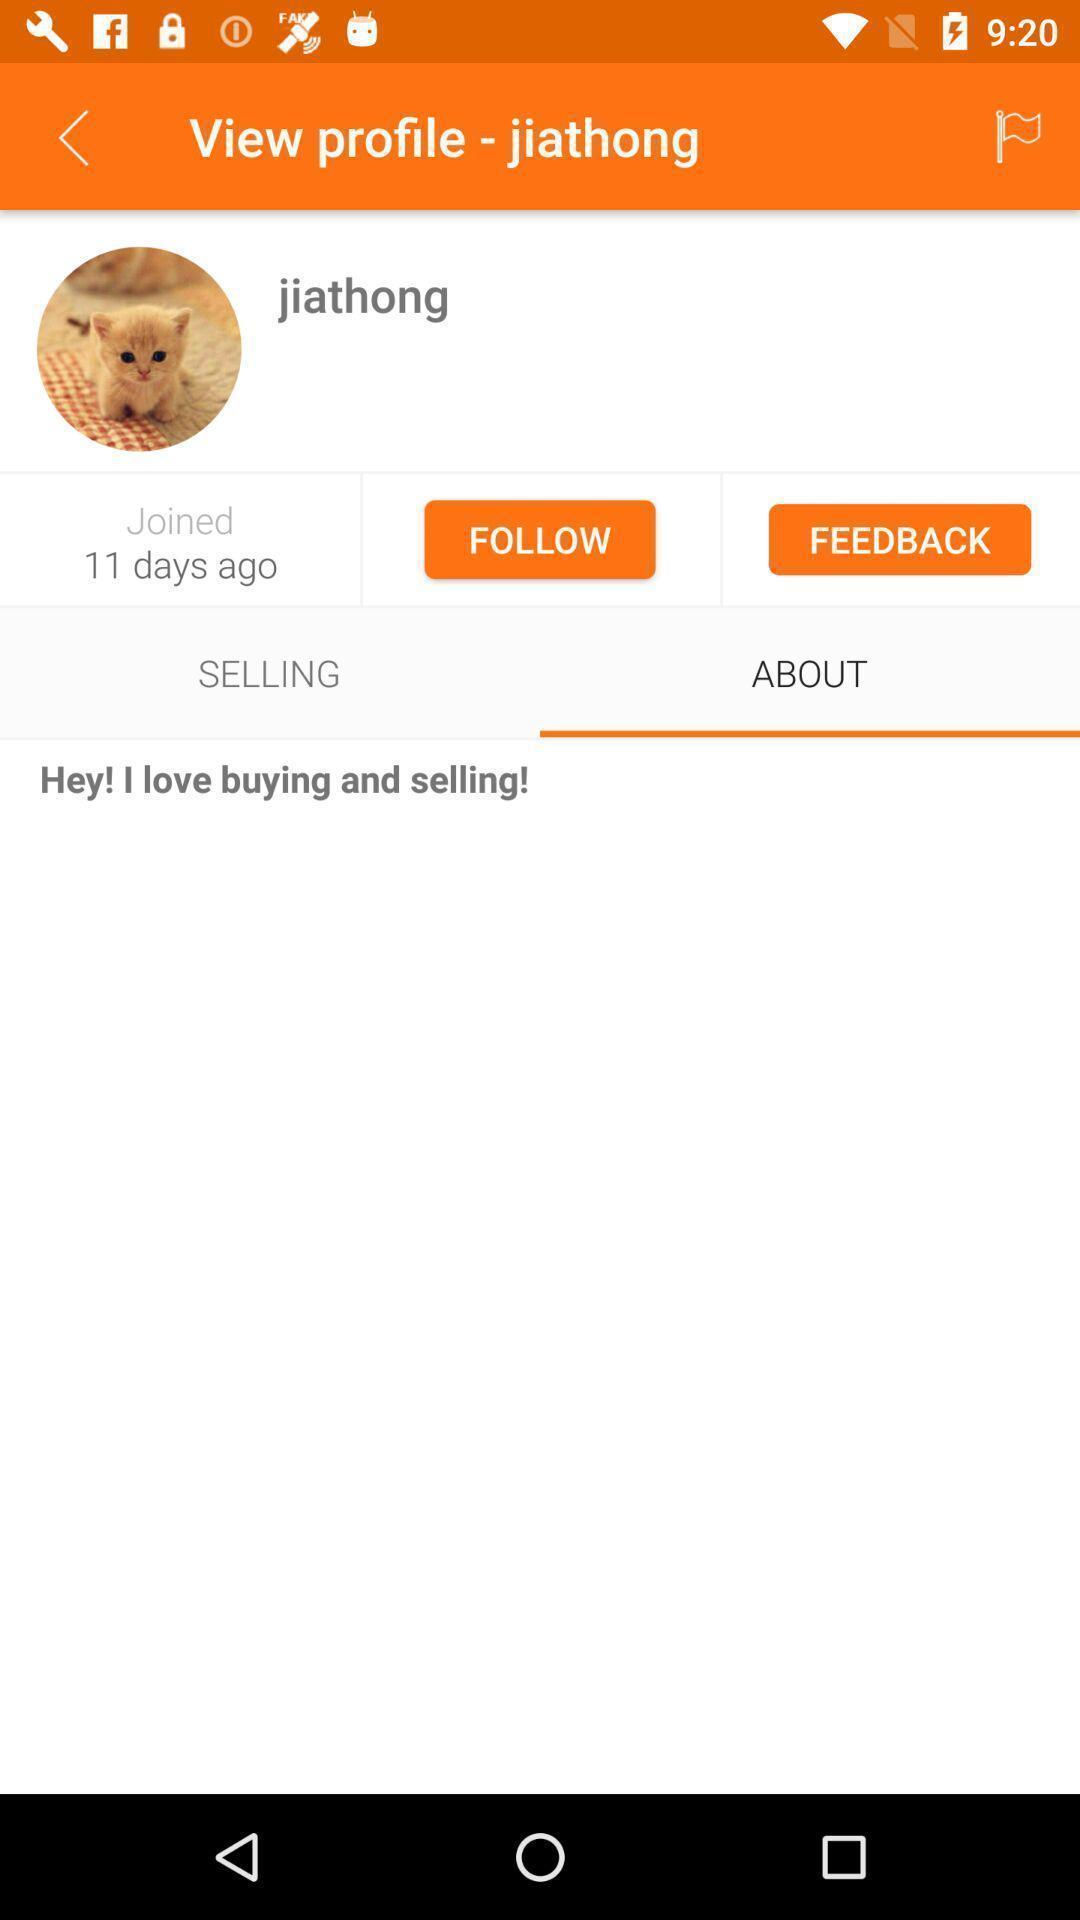Please provide a description for this image. Screen is showing user profile page. 